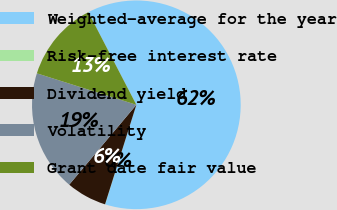Convert chart. <chart><loc_0><loc_0><loc_500><loc_500><pie_chart><fcel>Weighted-average for the year<fcel>Risk-free interest rate<fcel>Dividend yield<fcel>Volatility<fcel>Grant date fair value<nl><fcel>62.44%<fcel>0.03%<fcel>6.27%<fcel>18.75%<fcel>12.51%<nl></chart> 